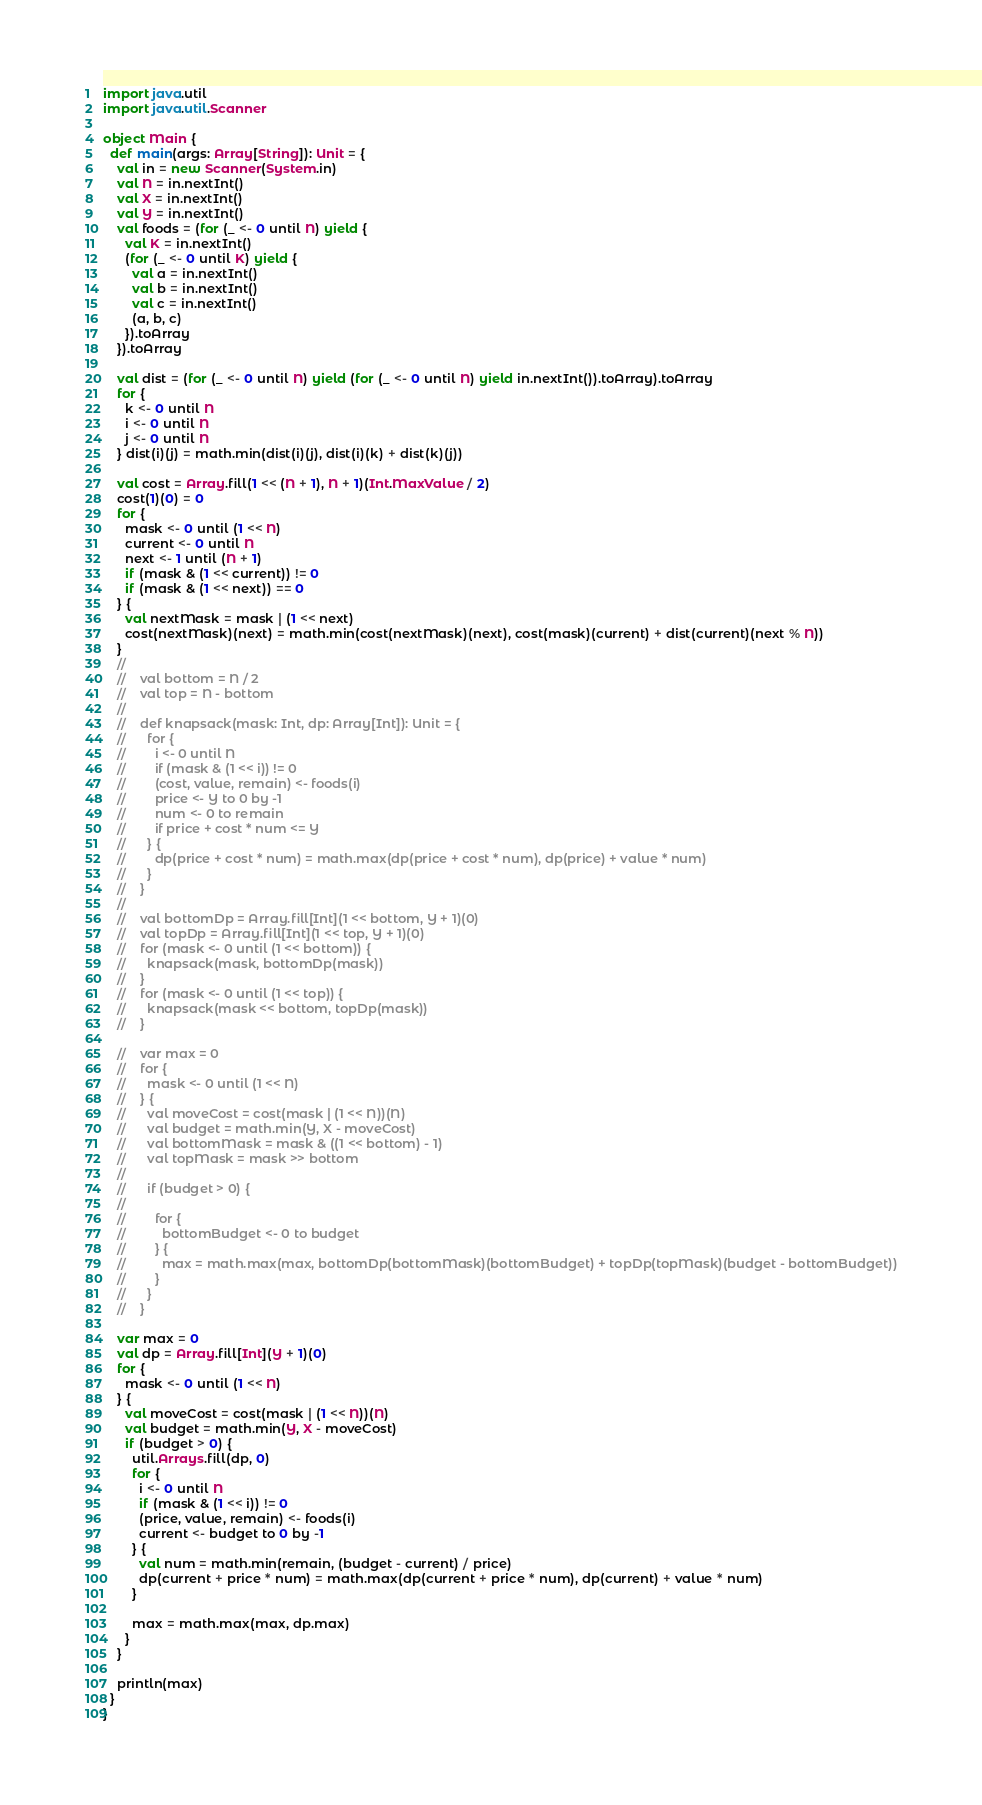<code> <loc_0><loc_0><loc_500><loc_500><_Scala_>import java.util
import java.util.Scanner

object Main {
  def main(args: Array[String]): Unit = {
    val in = new Scanner(System.in)
    val N = in.nextInt()
    val X = in.nextInt()
    val Y = in.nextInt()
    val foods = (for (_ <- 0 until N) yield {
      val K = in.nextInt()
      (for (_ <- 0 until K) yield {
        val a = in.nextInt()
        val b = in.nextInt()
        val c = in.nextInt()
        (a, b, c)
      }).toArray
    }).toArray

    val dist = (for (_ <- 0 until N) yield (for (_ <- 0 until N) yield in.nextInt()).toArray).toArray
    for {
      k <- 0 until N
      i <- 0 until N
      j <- 0 until N
    } dist(i)(j) = math.min(dist(i)(j), dist(i)(k) + dist(k)(j))

    val cost = Array.fill(1 << (N + 1), N + 1)(Int.MaxValue / 2)
    cost(1)(0) = 0
    for {
      mask <- 0 until (1 << N)
      current <- 0 until N
      next <- 1 until (N + 1)
      if (mask & (1 << current)) != 0
      if (mask & (1 << next)) == 0
    } {
      val nextMask = mask | (1 << next)
      cost(nextMask)(next) = math.min(cost(nextMask)(next), cost(mask)(current) + dist(current)(next % N))
    }
    //
    //    val bottom = N / 2
    //    val top = N - bottom
    //
    //    def knapsack(mask: Int, dp: Array[Int]): Unit = {
    //      for {
    //        i <- 0 until N
    //        if (mask & (1 << i)) != 0
    //        (cost, value, remain) <- foods(i)
    //        price <- Y to 0 by -1
    //        num <- 0 to remain
    //        if price + cost * num <= Y
    //      } {
    //        dp(price + cost * num) = math.max(dp(price + cost * num), dp(price) + value * num)
    //      }
    //    }
    //
    //    val bottomDp = Array.fill[Int](1 << bottom, Y + 1)(0)
    //    val topDp = Array.fill[Int](1 << top, Y + 1)(0)
    //    for (mask <- 0 until (1 << bottom)) {
    //      knapsack(mask, bottomDp(mask))
    //    }
    //    for (mask <- 0 until (1 << top)) {
    //      knapsack(mask << bottom, topDp(mask))
    //    }

    //    var max = 0
    //    for {
    //      mask <- 0 until (1 << N)
    //    } {
    //      val moveCost = cost(mask | (1 << N))(N)
    //      val budget = math.min(Y, X - moveCost)
    //      val bottomMask = mask & ((1 << bottom) - 1)
    //      val topMask = mask >> bottom
    //
    //      if (budget > 0) {
    //
    //        for {
    //          bottomBudget <- 0 to budget
    //        } {
    //          max = math.max(max, bottomDp(bottomMask)(bottomBudget) + topDp(topMask)(budget - bottomBudget))
    //        }
    //      }
    //    }

    var max = 0
    val dp = Array.fill[Int](Y + 1)(0)
    for {
      mask <- 0 until (1 << N)
    } {
      val moveCost = cost(mask | (1 << N))(N)
      val budget = math.min(Y, X - moveCost)
      if (budget > 0) {
        util.Arrays.fill(dp, 0)
        for {
          i <- 0 until N
          if (mask & (1 << i)) != 0
          (price, value, remain) <- foods(i)
          current <- budget to 0 by -1
        } {
          val num = math.min(remain, (budget - current) / price)
          dp(current + price * num) = math.max(dp(current + price * num), dp(current) + value * num)
        }

        max = math.max(max, dp.max)
      }
    }

    println(max)
  }
}</code> 